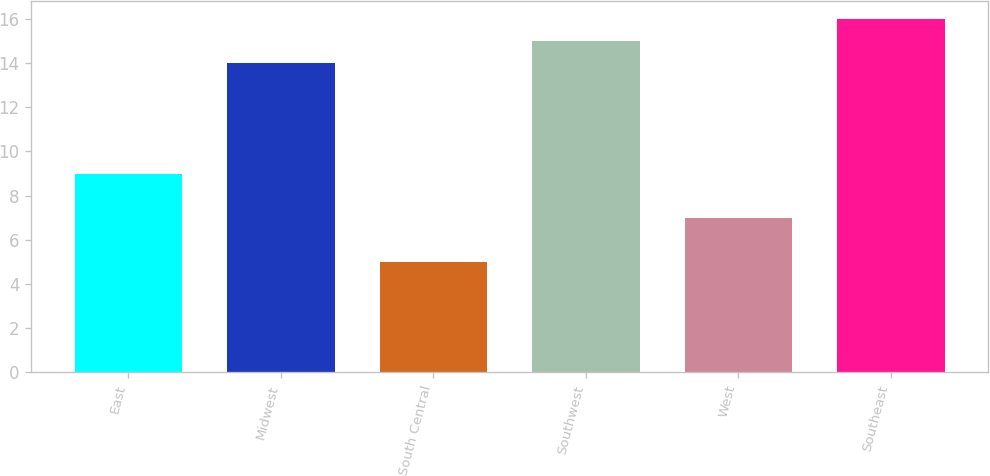Convert chart to OTSL. <chart><loc_0><loc_0><loc_500><loc_500><bar_chart><fcel>East<fcel>Midwest<fcel>South Central<fcel>Southwest<fcel>West<fcel>Southeast<nl><fcel>9<fcel>14<fcel>5<fcel>15<fcel>7<fcel>16<nl></chart> 